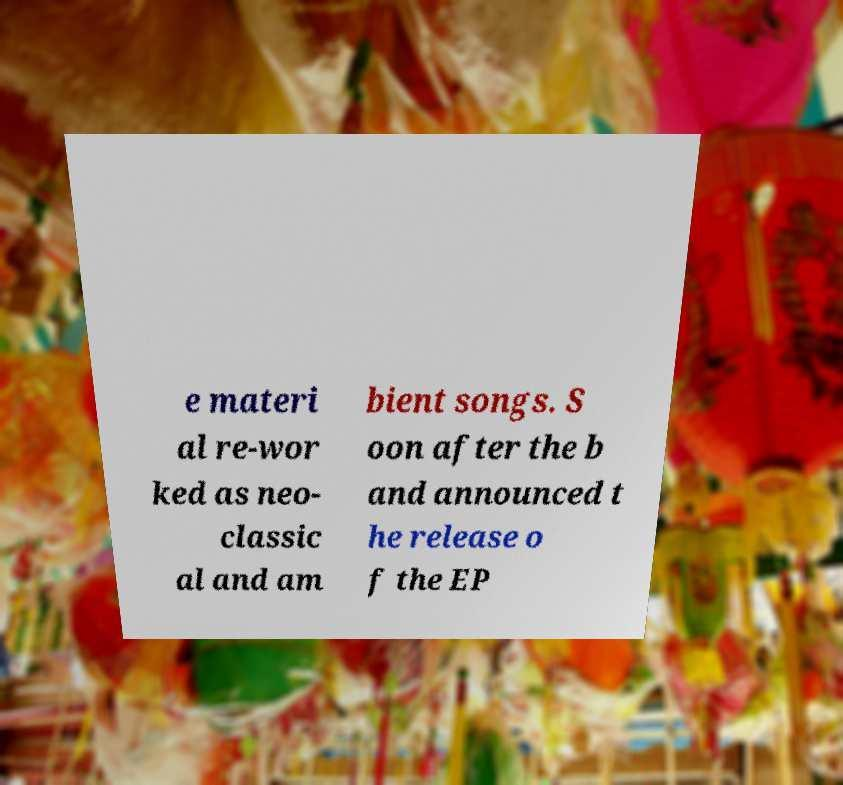Could you extract and type out the text from this image? e materi al re-wor ked as neo- classic al and am bient songs. S oon after the b and announced t he release o f the EP 